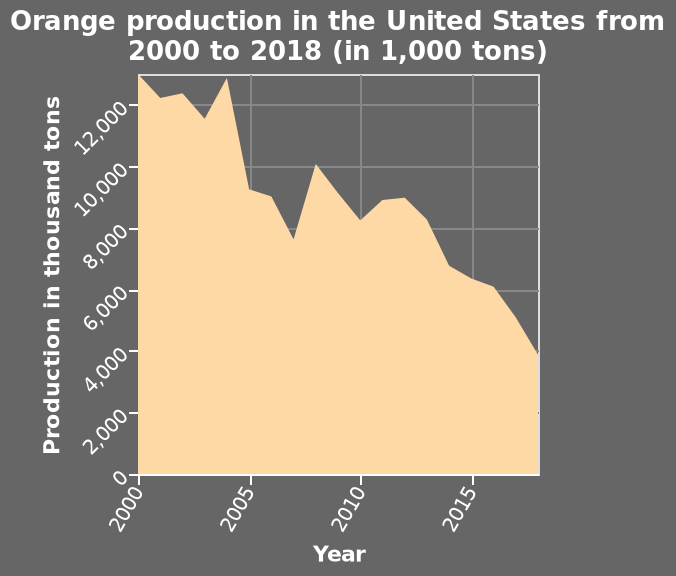<image>
What has happened to orange production in the US compared to the year 2000?  Orange production in the US has fallen dramatically compared to the year 2000. What is the trend in orange production in the US compared to the year 2000?  The trend indicates a significant drop in orange production in the US compared to the year 2000. How has orange production in the US changed since 2000?  Orange production in the US has seen a significant decline since 2000. What is being represented on the x-axis of the area plot? The x-axis of the area plot represents the years from 2000 to 2018. Does the y-axis of the area plot represent the years from 2000 to 2018? No.The x-axis of the area plot represents the years from 2000 to 2018. 